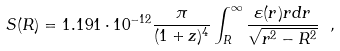Convert formula to latex. <formula><loc_0><loc_0><loc_500><loc_500>S ( R ) = 1 . 1 9 1 \cdot 1 0 ^ { - 1 2 } \frac { \pi } { ( 1 + z ) ^ { 4 } } \int ^ { \infty } _ { R } \frac { \varepsilon ( r ) r d r } { \sqrt { r ^ { 2 } - R ^ { 2 } } } \ ,</formula> 